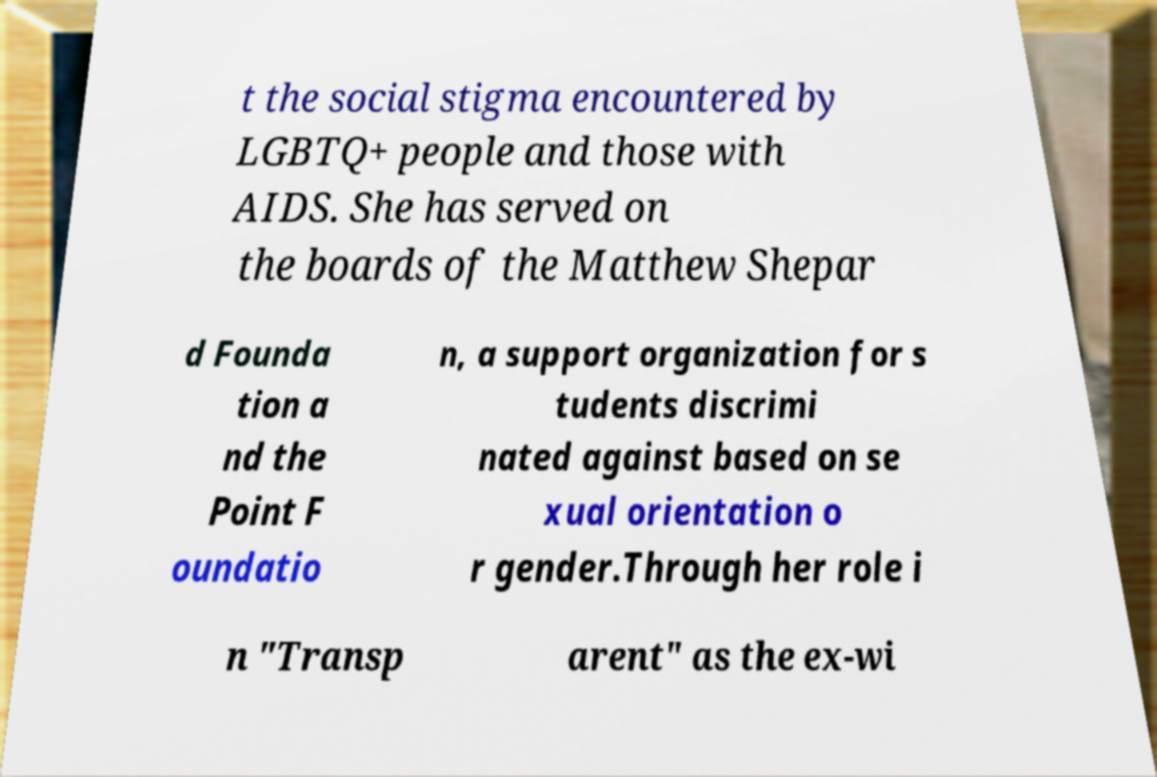For documentation purposes, I need the text within this image transcribed. Could you provide that? t the social stigma encountered by LGBTQ+ people and those with AIDS. She has served on the boards of the Matthew Shepar d Founda tion a nd the Point F oundatio n, a support organization for s tudents discrimi nated against based on se xual orientation o r gender.Through her role i n "Transp arent" as the ex-wi 